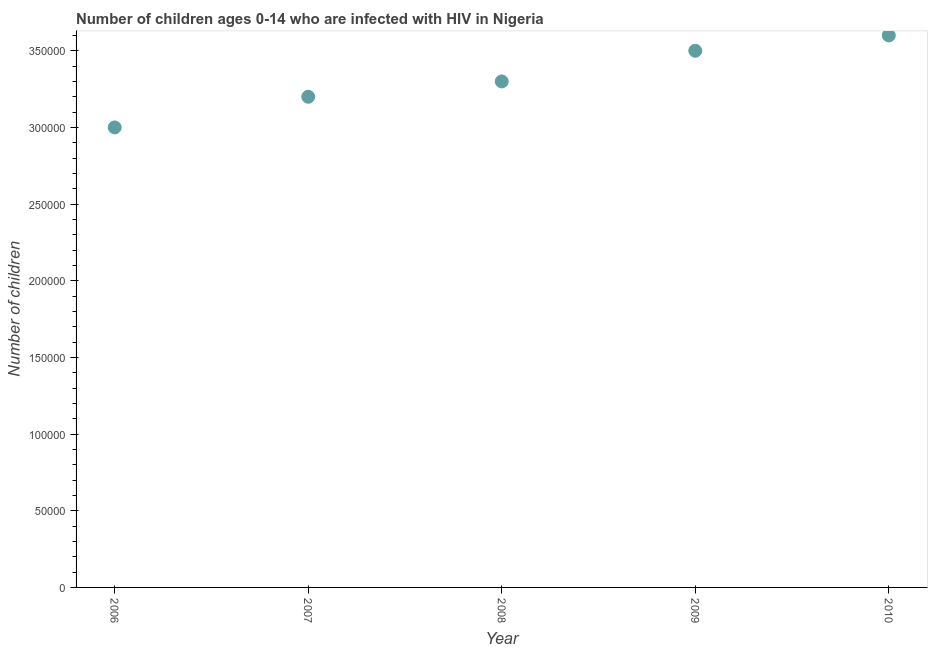What is the number of children living with hiv in 2007?
Give a very brief answer. 3.20e+05. Across all years, what is the maximum number of children living with hiv?
Give a very brief answer. 3.60e+05. Across all years, what is the minimum number of children living with hiv?
Make the answer very short. 3.00e+05. In which year was the number of children living with hiv minimum?
Keep it short and to the point. 2006. What is the sum of the number of children living with hiv?
Ensure brevity in your answer.  1.66e+06. What is the difference between the number of children living with hiv in 2007 and 2008?
Give a very brief answer. -10000. What is the average number of children living with hiv per year?
Provide a succinct answer. 3.32e+05. In how many years, is the number of children living with hiv greater than 240000 ?
Offer a terse response. 5. What is the ratio of the number of children living with hiv in 2006 to that in 2008?
Provide a short and direct response. 0.91. Is the difference between the number of children living with hiv in 2007 and 2009 greater than the difference between any two years?
Offer a terse response. No. Is the sum of the number of children living with hiv in 2007 and 2008 greater than the maximum number of children living with hiv across all years?
Keep it short and to the point. Yes. What is the difference between the highest and the lowest number of children living with hiv?
Provide a short and direct response. 6.00e+04. Does the number of children living with hiv monotonically increase over the years?
Give a very brief answer. Yes. How many dotlines are there?
Keep it short and to the point. 1. Does the graph contain grids?
Your answer should be compact. No. What is the title of the graph?
Offer a terse response. Number of children ages 0-14 who are infected with HIV in Nigeria. What is the label or title of the Y-axis?
Provide a short and direct response. Number of children. What is the Number of children in 2006?
Ensure brevity in your answer.  3.00e+05. What is the Number of children in 2009?
Make the answer very short. 3.50e+05. What is the difference between the Number of children in 2006 and 2009?
Your answer should be compact. -5.00e+04. What is the difference between the Number of children in 2006 and 2010?
Offer a very short reply. -6.00e+04. What is the difference between the Number of children in 2007 and 2010?
Make the answer very short. -4.00e+04. What is the difference between the Number of children in 2008 and 2010?
Keep it short and to the point. -3.00e+04. What is the ratio of the Number of children in 2006 to that in 2007?
Ensure brevity in your answer.  0.94. What is the ratio of the Number of children in 2006 to that in 2008?
Provide a succinct answer. 0.91. What is the ratio of the Number of children in 2006 to that in 2009?
Your answer should be very brief. 0.86. What is the ratio of the Number of children in 2006 to that in 2010?
Your answer should be compact. 0.83. What is the ratio of the Number of children in 2007 to that in 2009?
Your answer should be very brief. 0.91. What is the ratio of the Number of children in 2007 to that in 2010?
Your answer should be very brief. 0.89. What is the ratio of the Number of children in 2008 to that in 2009?
Make the answer very short. 0.94. What is the ratio of the Number of children in 2008 to that in 2010?
Offer a very short reply. 0.92. What is the ratio of the Number of children in 2009 to that in 2010?
Your answer should be compact. 0.97. 